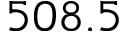Convert formula to latex. <formula><loc_0><loc_0><loc_500><loc_500>5 0 8 . 5</formula> 